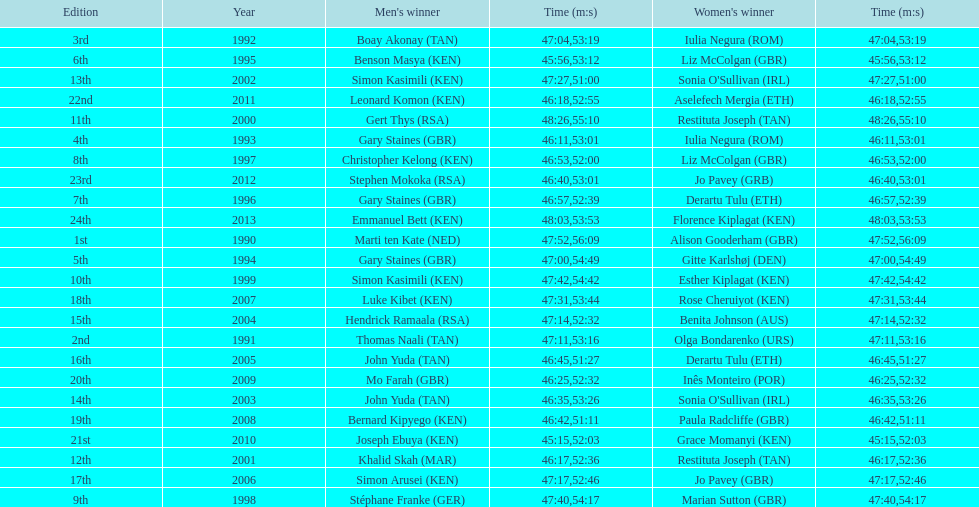What is the name of the first women's winner? Alison Gooderham. 